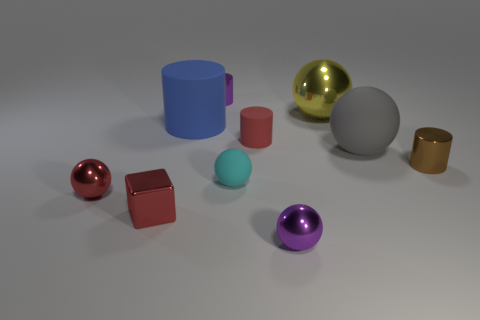Are there any other things that have the same color as the small matte cylinder?
Your answer should be very brief. Yes. How many other objects are the same size as the purple shiny ball?
Ensure brevity in your answer.  6. Is the color of the shiny block the same as the small rubber cylinder?
Make the answer very short. Yes. How many things are in front of the rubber thing that is to the left of the small purple metal object that is behind the large cylinder?
Ensure brevity in your answer.  7. What material is the brown cylinder on the right side of the tiny cylinder that is on the left side of the cyan sphere?
Keep it short and to the point. Metal. Are there any other gray objects that have the same shape as the big shiny object?
Keep it short and to the point. Yes. There is a cube that is the same size as the brown cylinder; what is its color?
Offer a terse response. Red. What number of objects are either purple objects behind the small cyan matte thing or shiny cylinders behind the blue cylinder?
Make the answer very short. 1. What number of objects are tiny red shiny objects or tiny purple metallic things?
Offer a very short reply. 4. There is a shiny object that is behind the brown object and on the left side of the cyan matte thing; how big is it?
Keep it short and to the point. Small. 